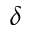<formula> <loc_0><loc_0><loc_500><loc_500>\delta</formula> 